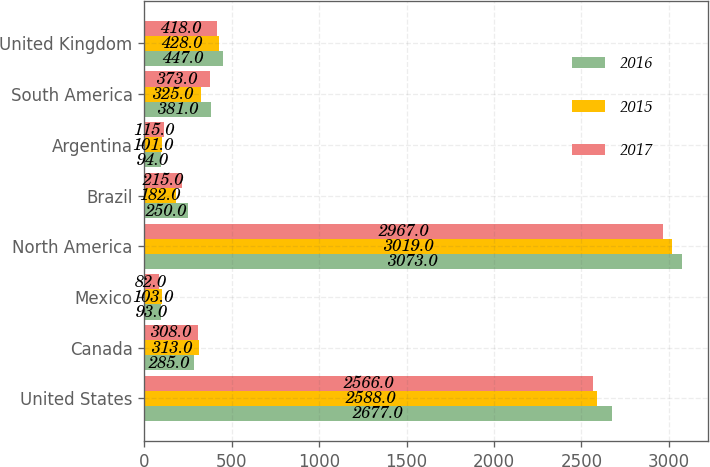Convert chart. <chart><loc_0><loc_0><loc_500><loc_500><stacked_bar_chart><ecel><fcel>United States<fcel>Canada<fcel>Mexico<fcel>North America<fcel>Brazil<fcel>Argentina<fcel>South America<fcel>United Kingdom<nl><fcel>2016<fcel>2677<fcel>285<fcel>93<fcel>3073<fcel>250<fcel>94<fcel>381<fcel>447<nl><fcel>2015<fcel>2588<fcel>313<fcel>103<fcel>3019<fcel>182<fcel>101<fcel>325<fcel>428<nl><fcel>2017<fcel>2566<fcel>308<fcel>82<fcel>2967<fcel>215<fcel>115<fcel>373<fcel>418<nl></chart> 